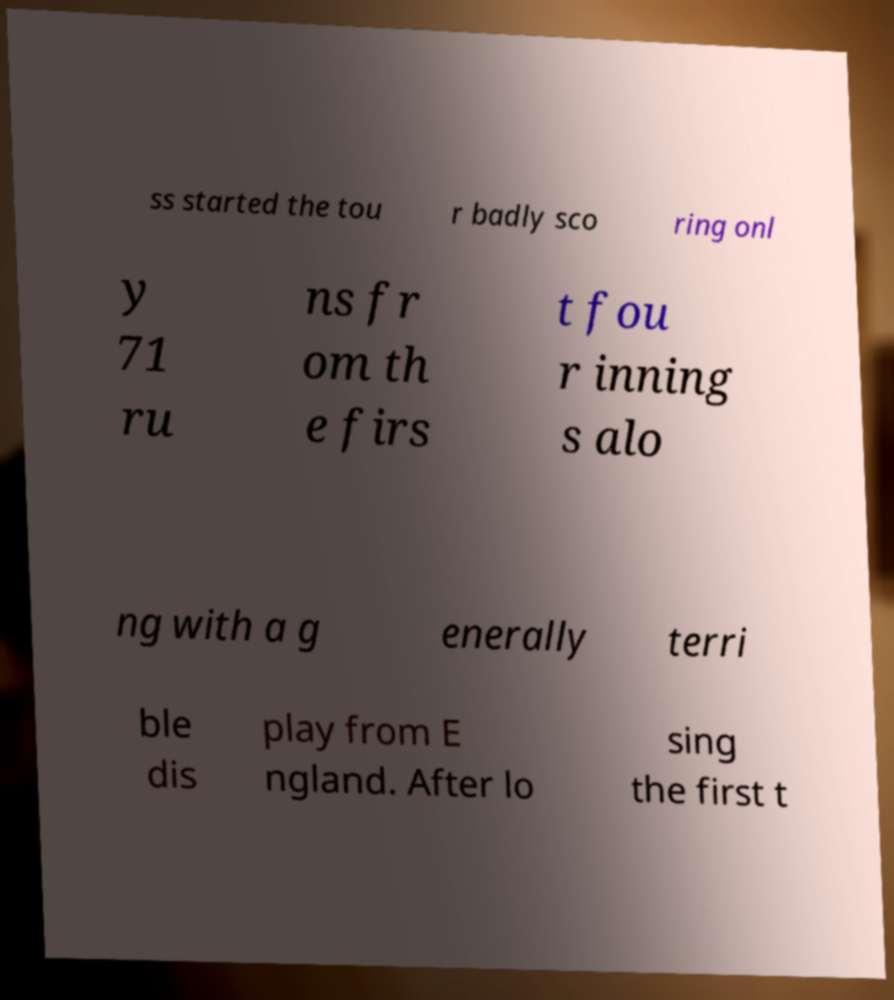Could you extract and type out the text from this image? ss started the tou r badly sco ring onl y 71 ru ns fr om th e firs t fou r inning s alo ng with a g enerally terri ble dis play from E ngland. After lo sing the first t 